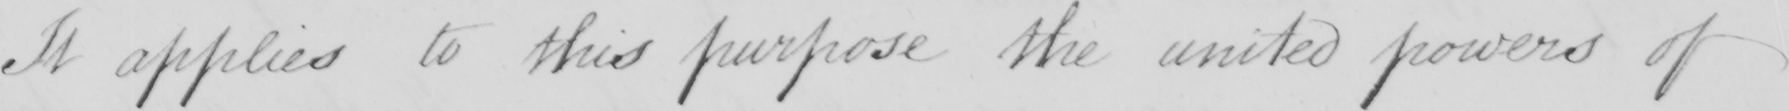Please transcribe the handwritten text in this image. It applies to this purpose the united powers of 